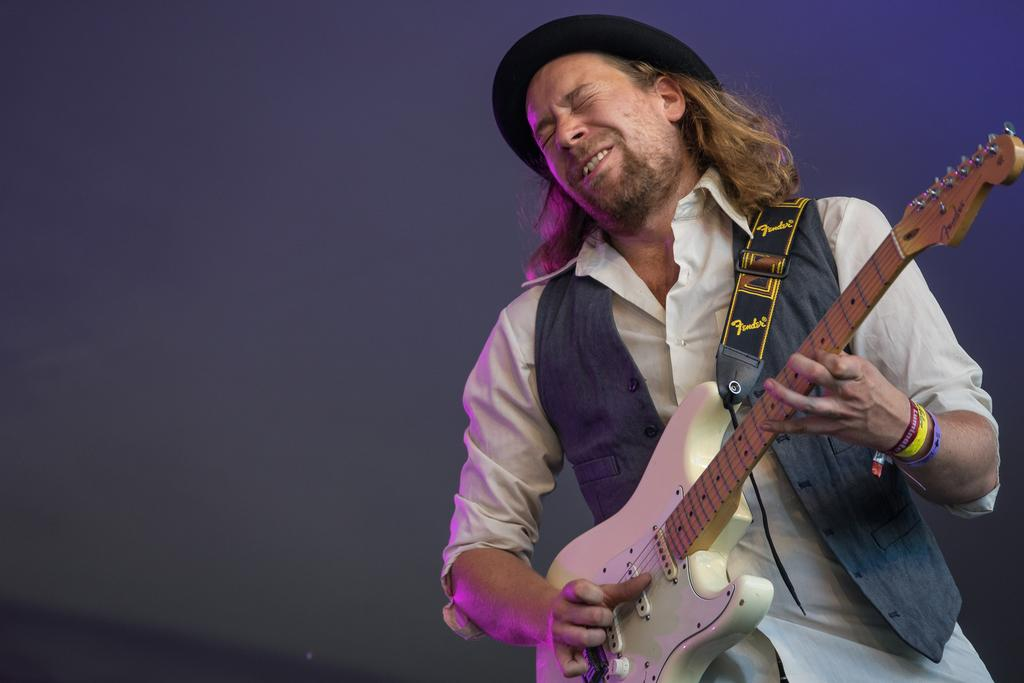What is the main subject of the image? There is a person in the image. What is the person holding in the image? The person is holding a guitar. What is the person doing with the guitar? The person is playing the guitar. Where is the nest located in the image? There is no nest present in the image. What is the person's sister doing in the image? There is no mention of a sister in the image, so we cannot determine what they might be doing. 